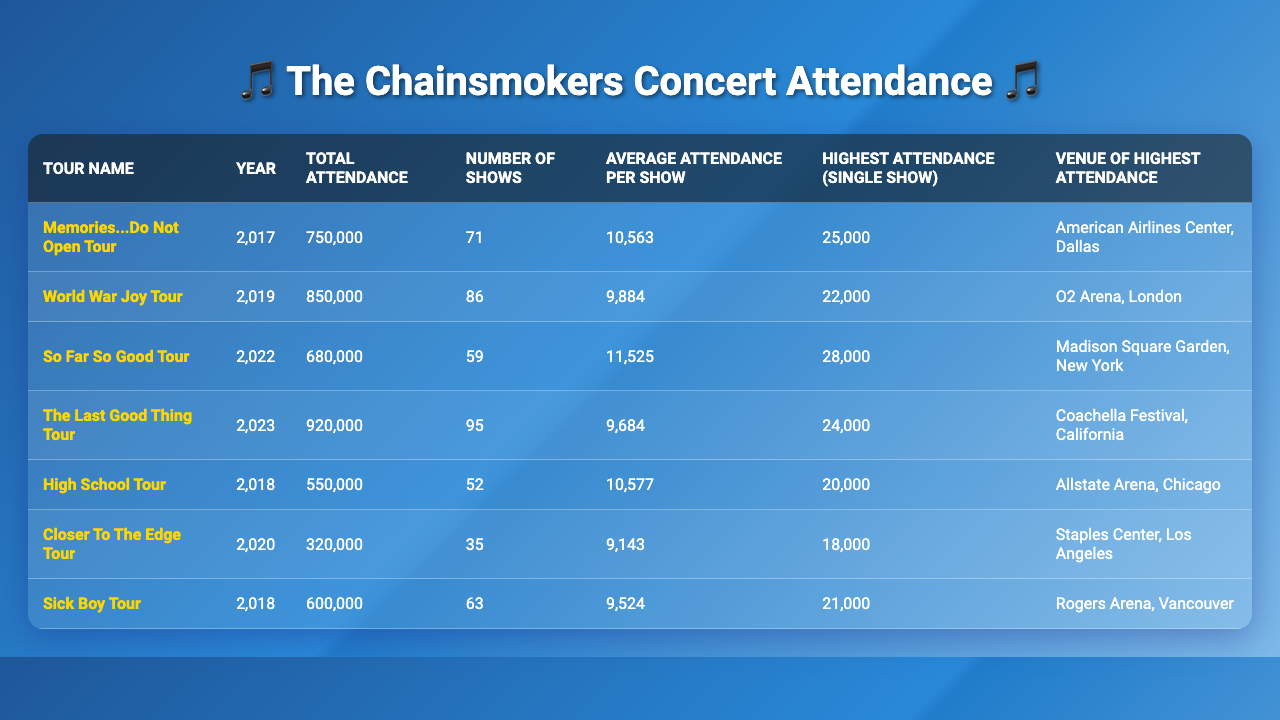What is the highest attendance for a single show in The Chainsmokers' tours? The highest attendance for a single show listed in the table is 28,000, which occurred during the So Far So Good Tour at Madison Square Garden, New York.
Answer: 28,000 Which tour had the lowest total attendance? The tour with the lowest total attendance is the Closer To The Edge Tour in 2020, with a total of 320,000 attendees.
Answer: Closer To The Edge Tour What was the average attendance per show for the World War Joy Tour? The average attendance per show for the World War Joy Tour is calculated by taking the total attendance (850,000) and dividing it by the number of shows (86), which equals approximately 9,884.
Answer: 9,884 How many total shows were there across all tours in the table? The total shows across all tours can be calculated by summing the number of shows from each tour: 71 + 86 + 59 + 95 + 52 + 35 + 63 = 457.
Answer: 457 True or False: The Memories...Do Not Open Tour had a higher highest attendance than the So Far So Good Tour. The highest attendance for the Memories...Do Not Open Tour is 25,000, while for the So Far So Good Tour it is 28,000. Therefore, the statement is false.
Answer: False What is the average attendance per show for the tour with the highest total attendance? The tour with the highest total attendance is The Last Good Thing Tour with 920,000 attendees over 95 shows. The average attendance per show is calculated as 920,000 / 95, which equals approximately 9,684.
Answer: 9,684 Which venue had the highest attendance for a single show? The venue with the highest attendance for a single show is Madison Square Garden in New York, with a highest attendance of 28,000 during the So Far So Good Tour.
Answer: Madison Square Garden For which tour was the highest attendance recorded at the Coachella Festival? The highest attendance at Coachella Festival is attributed to The Last Good Thing Tour, with a highest attendance of 24,000 for a single show.
Answer: The Last Good Thing Tour If you combine the total attendance of the High School Tour and Sick Boy Tour, what is the sum? The total attendance for the High School Tour is 550,000, and for the Sick Boy Tour, it is 600,000. Adding these two gives 550,000 + 600,000 = 1,150,000.
Answer: 1,150,000 Which tour had a higher average attendance: the World War Joy Tour or the Sick Boy Tour? The average attendance for the World War Joy Tour is approximately 9,884, while for the Sick Boy Tour it is approximately 9,524. Therefore, the World War Joy Tour had a higher average attendance.
Answer: World War Joy Tour 